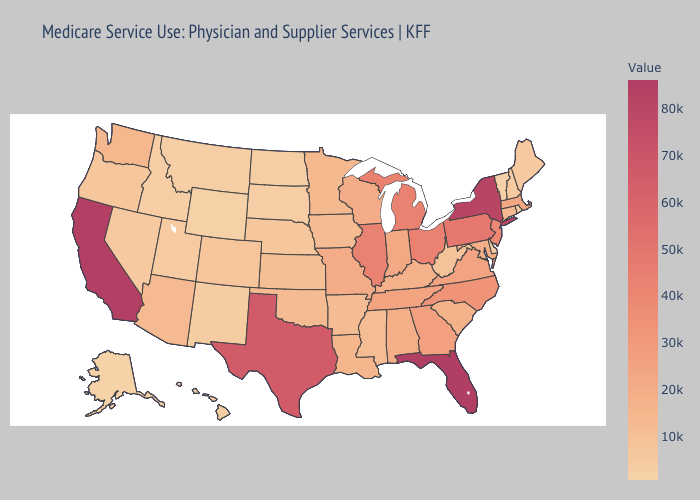Does Pennsylvania have the highest value in the Northeast?
Quick response, please. No. Which states have the lowest value in the USA?
Quick response, please. Alaska. Among the states that border Iowa , does Minnesota have the lowest value?
Concise answer only. No. 